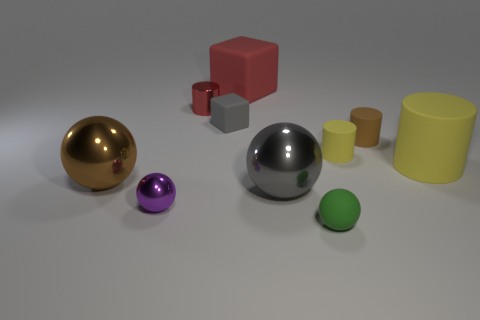Subtract all brown cylinders. How many cylinders are left? 3 Subtract all red cubes. How many cubes are left? 1 Subtract all cylinders. How many objects are left? 6 Add 6 brown matte cylinders. How many brown matte cylinders are left? 7 Add 6 cyan metal cylinders. How many cyan metal cylinders exist? 6 Subtract 0 green cylinders. How many objects are left? 10 Subtract 2 blocks. How many blocks are left? 0 Subtract all red cubes. Subtract all purple balls. How many cubes are left? 1 Subtract all green cubes. How many yellow cylinders are left? 2 Subtract all tiny green spheres. Subtract all big brown objects. How many objects are left? 8 